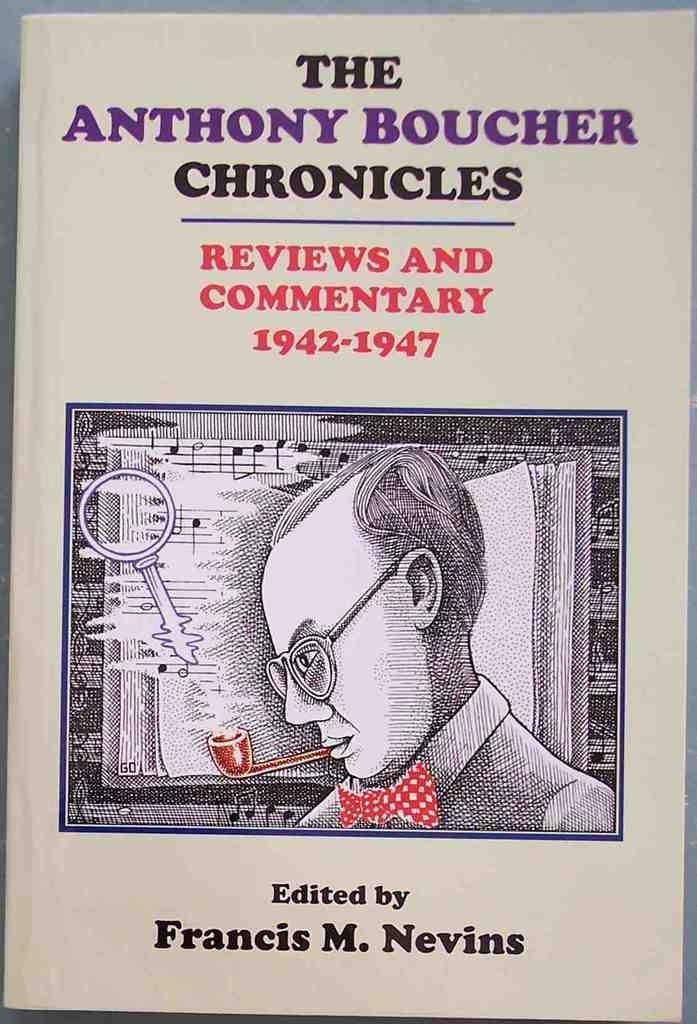<image>
Present a compact description of the photo's key features. A book cover of a book that was edited by somebody named Francis. 